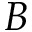<formula> <loc_0><loc_0><loc_500><loc_500>B</formula> 